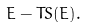Convert formula to latex. <formula><loc_0><loc_0><loc_500><loc_500>E - T S ( E ) .</formula> 